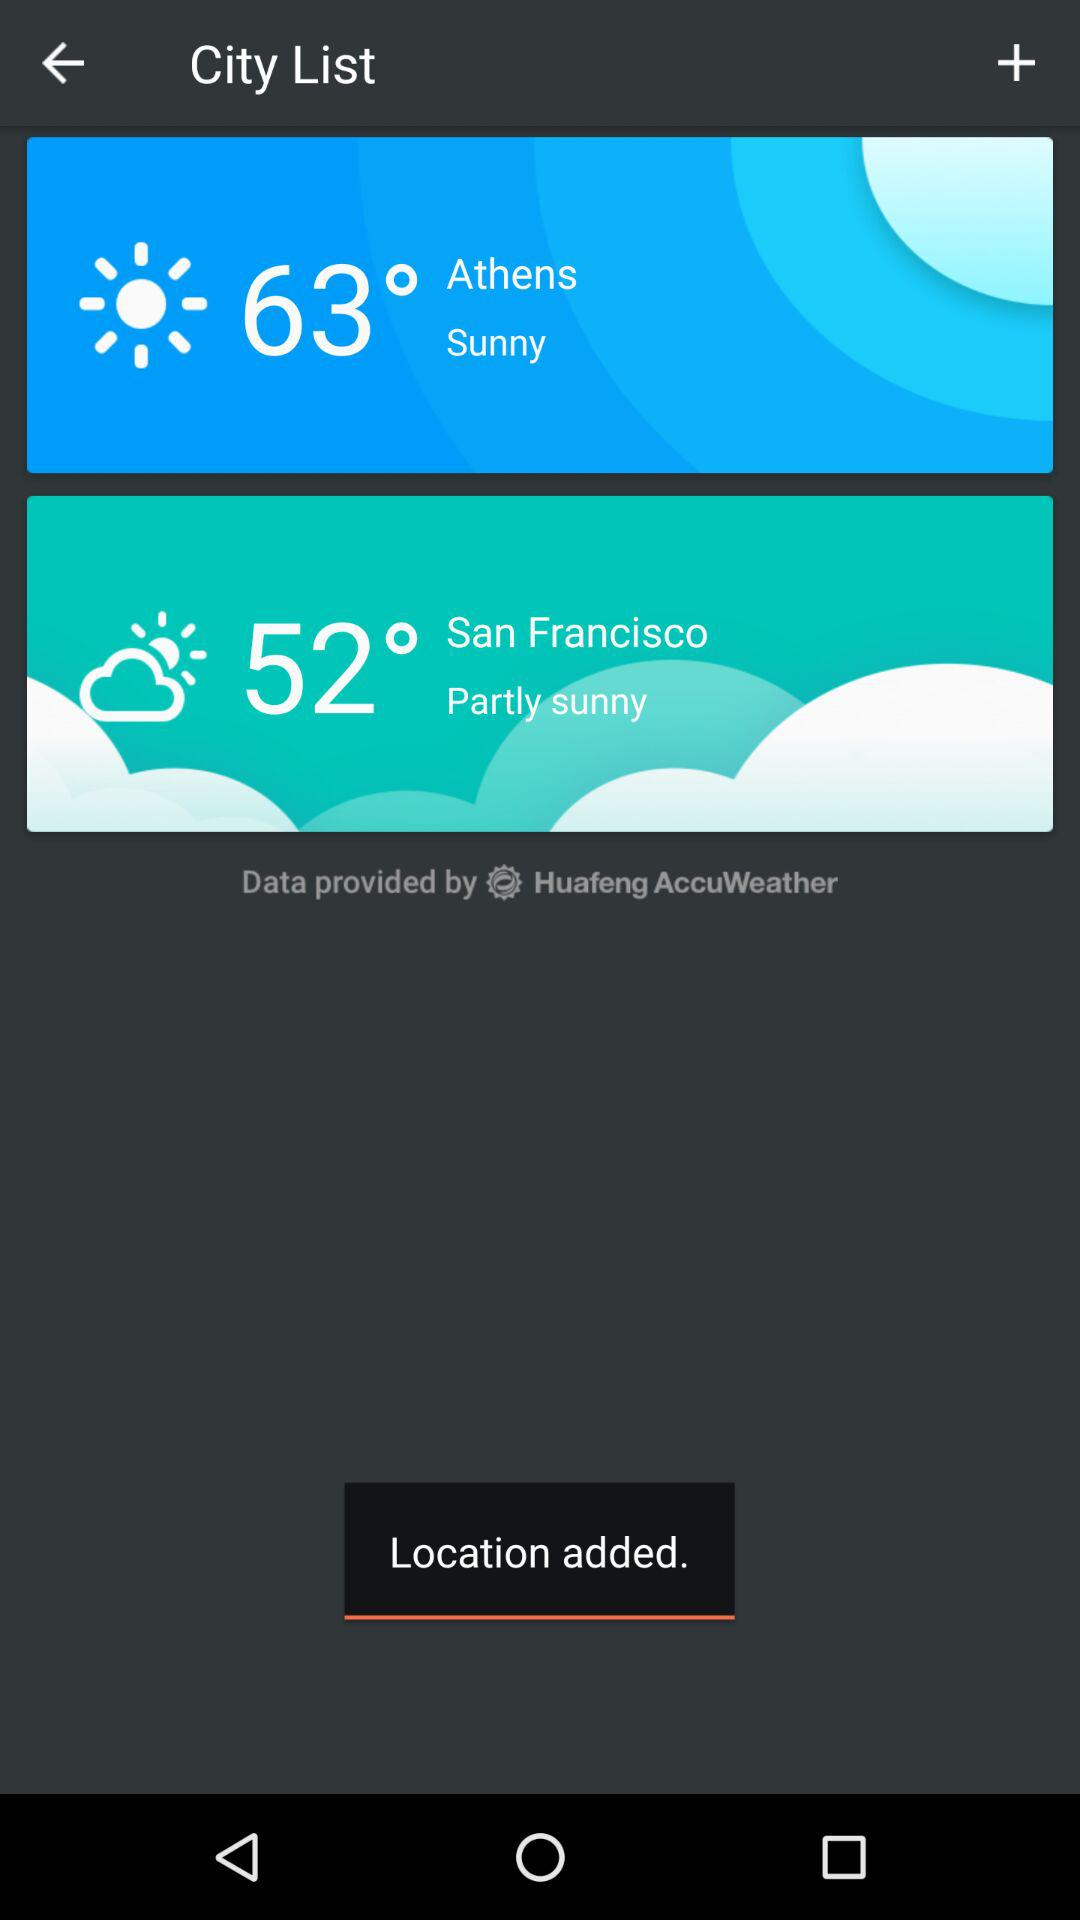Which city has a higher temperature, Athens or San Francisco?
Answer the question using a single word or phrase. Athens 